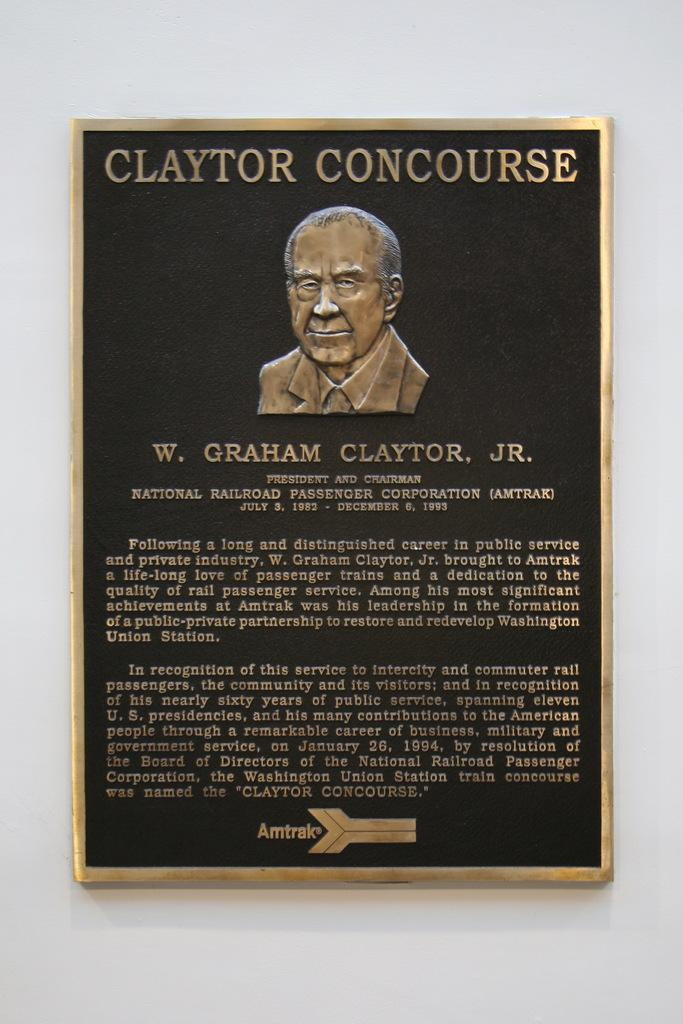What object is present in the image that typically holds a photograph? There is a photo frame in the image. Where is the photo frame located in the image? The photo frame is attached to the wall. What can be seen inside the photo frame? There is a depiction of a person in the photo frame. Are there any words or letters in the photo frame? Yes, there is text in the photo frame. How many feet are visible in the image? There are no feet visible in the image; it features a photo frame with a depiction of a person and text. 